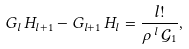<formula> <loc_0><loc_0><loc_500><loc_500>G _ { l } \, H _ { l + 1 } - G _ { l + 1 } \, H _ { l } = \frac { l ! } { \rho \, ^ { l } \, \mathcal { G } _ { 1 } } ,</formula> 